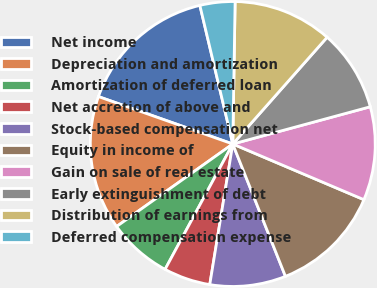Convert chart to OTSL. <chart><loc_0><loc_0><loc_500><loc_500><pie_chart><fcel>Net income<fcel>Depreciation and amortization<fcel>Amortization of deferred loan<fcel>Net accretion of above and<fcel>Stock-based compensation net<fcel>Equity in income of<fcel>Gain on sale of real estate<fcel>Early extinguishment of debt<fcel>Distribution of earnings from<fcel>Deferred compensation expense<nl><fcel>15.89%<fcel>15.23%<fcel>7.29%<fcel>5.3%<fcel>8.61%<fcel>12.58%<fcel>10.6%<fcel>9.27%<fcel>11.26%<fcel>3.97%<nl></chart> 